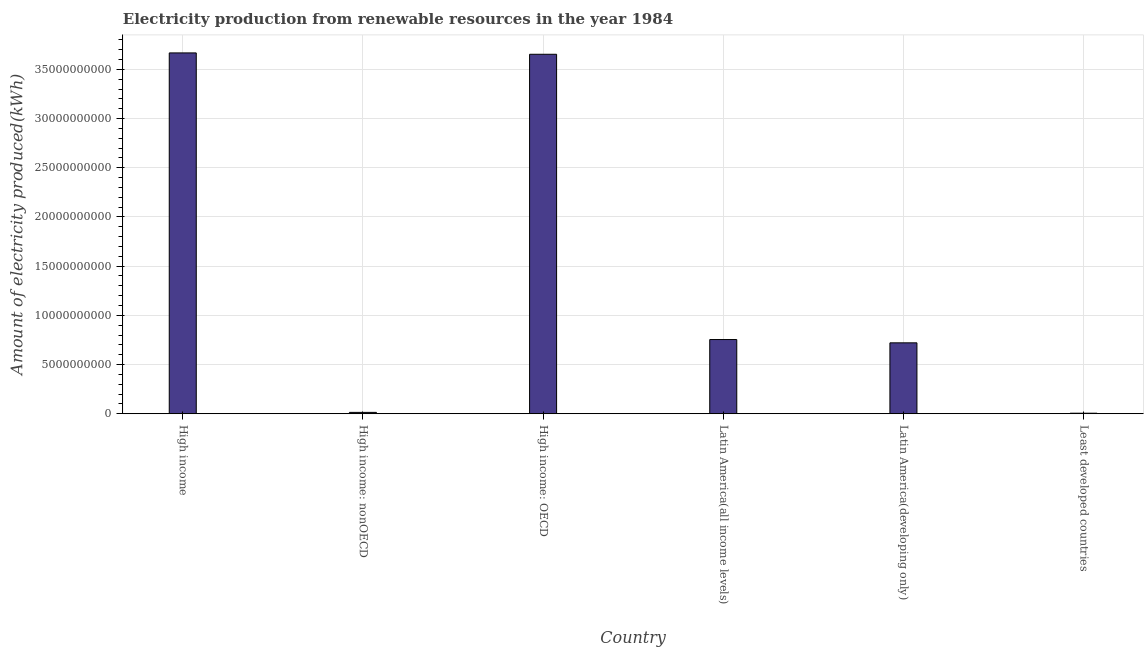What is the title of the graph?
Offer a very short reply. Electricity production from renewable resources in the year 1984. What is the label or title of the Y-axis?
Provide a succinct answer. Amount of electricity produced(kWh). What is the amount of electricity produced in Latin America(all income levels)?
Give a very brief answer. 7.54e+09. Across all countries, what is the maximum amount of electricity produced?
Your answer should be very brief. 3.67e+1. Across all countries, what is the minimum amount of electricity produced?
Give a very brief answer. 5.40e+07. In which country was the amount of electricity produced minimum?
Offer a very short reply. Least developed countries. What is the sum of the amount of electricity produced?
Ensure brevity in your answer.  8.81e+1. What is the difference between the amount of electricity produced in Latin America(all income levels) and Latin America(developing only)?
Offer a terse response. 3.35e+08. What is the average amount of electricity produced per country?
Your response must be concise. 1.47e+1. What is the median amount of electricity produced?
Offer a terse response. 7.37e+09. What is the ratio of the amount of electricity produced in High income to that in Latin America(developing only)?
Give a very brief answer. 5.09. Is the amount of electricity produced in Latin America(developing only) less than that in Least developed countries?
Offer a very short reply. No. Is the difference between the amount of electricity produced in High income: nonOECD and Least developed countries greater than the difference between any two countries?
Your response must be concise. No. What is the difference between the highest and the second highest amount of electricity produced?
Your response must be concise. 1.38e+08. Is the sum of the amount of electricity produced in Latin America(all income levels) and Least developed countries greater than the maximum amount of electricity produced across all countries?
Provide a short and direct response. No. What is the difference between the highest and the lowest amount of electricity produced?
Offer a terse response. 3.66e+1. In how many countries, is the amount of electricity produced greater than the average amount of electricity produced taken over all countries?
Your answer should be compact. 2. How many bars are there?
Keep it short and to the point. 6. Are all the bars in the graph horizontal?
Ensure brevity in your answer.  No. How many countries are there in the graph?
Offer a terse response. 6. Are the values on the major ticks of Y-axis written in scientific E-notation?
Offer a terse response. No. What is the Amount of electricity produced(kWh) of High income?
Your answer should be compact. 3.67e+1. What is the Amount of electricity produced(kWh) in High income: nonOECD?
Ensure brevity in your answer.  1.38e+08. What is the Amount of electricity produced(kWh) in High income: OECD?
Keep it short and to the point. 3.65e+1. What is the Amount of electricity produced(kWh) in Latin America(all income levels)?
Your answer should be very brief. 7.54e+09. What is the Amount of electricity produced(kWh) in Latin America(developing only)?
Your answer should be compact. 7.20e+09. What is the Amount of electricity produced(kWh) of Least developed countries?
Your answer should be very brief. 5.40e+07. What is the difference between the Amount of electricity produced(kWh) in High income and High income: nonOECD?
Keep it short and to the point. 3.65e+1. What is the difference between the Amount of electricity produced(kWh) in High income and High income: OECD?
Your response must be concise. 1.38e+08. What is the difference between the Amount of electricity produced(kWh) in High income and Latin America(all income levels)?
Provide a short and direct response. 2.91e+1. What is the difference between the Amount of electricity produced(kWh) in High income and Latin America(developing only)?
Give a very brief answer. 2.95e+1. What is the difference between the Amount of electricity produced(kWh) in High income and Least developed countries?
Your answer should be very brief. 3.66e+1. What is the difference between the Amount of electricity produced(kWh) in High income: nonOECD and High income: OECD?
Your answer should be compact. -3.64e+1. What is the difference between the Amount of electricity produced(kWh) in High income: nonOECD and Latin America(all income levels)?
Give a very brief answer. -7.40e+09. What is the difference between the Amount of electricity produced(kWh) in High income: nonOECD and Latin America(developing only)?
Offer a very short reply. -7.07e+09. What is the difference between the Amount of electricity produced(kWh) in High income: nonOECD and Least developed countries?
Make the answer very short. 8.40e+07. What is the difference between the Amount of electricity produced(kWh) in High income: OECD and Latin America(all income levels)?
Make the answer very short. 2.90e+1. What is the difference between the Amount of electricity produced(kWh) in High income: OECD and Latin America(developing only)?
Offer a very short reply. 2.93e+1. What is the difference between the Amount of electricity produced(kWh) in High income: OECD and Least developed countries?
Your answer should be compact. 3.65e+1. What is the difference between the Amount of electricity produced(kWh) in Latin America(all income levels) and Latin America(developing only)?
Provide a succinct answer. 3.35e+08. What is the difference between the Amount of electricity produced(kWh) in Latin America(all income levels) and Least developed countries?
Your answer should be compact. 7.49e+09. What is the difference between the Amount of electricity produced(kWh) in Latin America(developing only) and Least developed countries?
Provide a succinct answer. 7.15e+09. What is the ratio of the Amount of electricity produced(kWh) in High income to that in High income: nonOECD?
Ensure brevity in your answer.  265.72. What is the ratio of the Amount of electricity produced(kWh) in High income to that in High income: OECD?
Your answer should be compact. 1. What is the ratio of the Amount of electricity produced(kWh) in High income to that in Latin America(all income levels)?
Offer a terse response. 4.86. What is the ratio of the Amount of electricity produced(kWh) in High income to that in Latin America(developing only)?
Make the answer very short. 5.09. What is the ratio of the Amount of electricity produced(kWh) in High income to that in Least developed countries?
Keep it short and to the point. 679.06. What is the ratio of the Amount of electricity produced(kWh) in High income: nonOECD to that in High income: OECD?
Provide a short and direct response. 0. What is the ratio of the Amount of electricity produced(kWh) in High income: nonOECD to that in Latin America(all income levels)?
Keep it short and to the point. 0.02. What is the ratio of the Amount of electricity produced(kWh) in High income: nonOECD to that in Latin America(developing only)?
Offer a very short reply. 0.02. What is the ratio of the Amount of electricity produced(kWh) in High income: nonOECD to that in Least developed countries?
Your answer should be very brief. 2.56. What is the ratio of the Amount of electricity produced(kWh) in High income: OECD to that in Latin America(all income levels)?
Ensure brevity in your answer.  4.84. What is the ratio of the Amount of electricity produced(kWh) in High income: OECD to that in Latin America(developing only)?
Keep it short and to the point. 5.07. What is the ratio of the Amount of electricity produced(kWh) in High income: OECD to that in Least developed countries?
Provide a short and direct response. 676.5. What is the ratio of the Amount of electricity produced(kWh) in Latin America(all income levels) to that in Latin America(developing only)?
Offer a very short reply. 1.05. What is the ratio of the Amount of electricity produced(kWh) in Latin America(all income levels) to that in Least developed countries?
Make the answer very short. 139.63. What is the ratio of the Amount of electricity produced(kWh) in Latin America(developing only) to that in Least developed countries?
Your response must be concise. 133.43. 